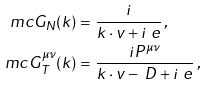Convert formula to latex. <formula><loc_0><loc_0><loc_500><loc_500>\ m c { G } _ { N } ( k ) = & \ \frac { i } { k \cdot v + i \ e } \, , \\ \ m c { G } _ { T } ^ { \mu \nu } ( k ) = & \ \frac { i P ^ { \mu \nu } } { k \cdot v - \ D + i \ e } \, ,</formula> 